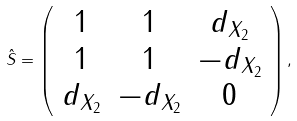Convert formula to latex. <formula><loc_0><loc_0><loc_500><loc_500>\hat { S } = \left ( \begin{array} { c c c } 1 & 1 & d _ { X _ { 2 } } \\ 1 & 1 & - d _ { X _ { 2 } } \\ d _ { X _ { 2 } } & - d _ { X _ { 2 } } & 0 \\ \end{array} \right ) ,</formula> 